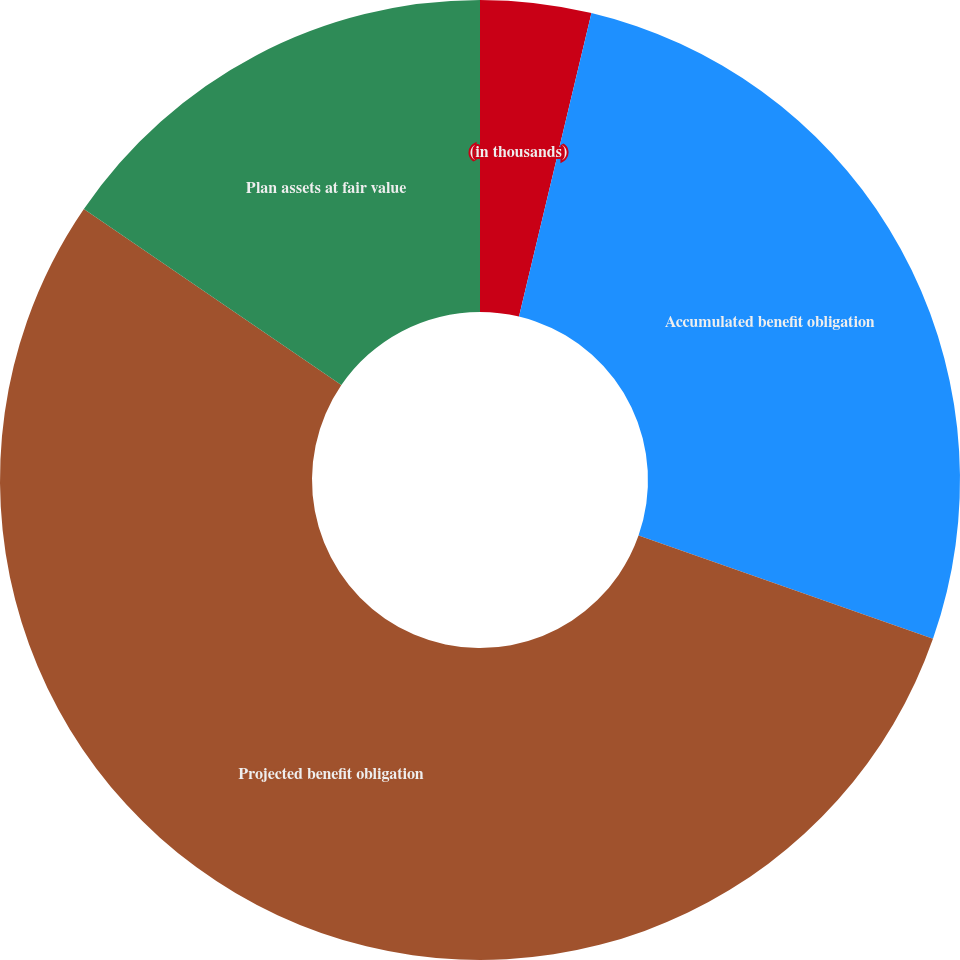Convert chart. <chart><loc_0><loc_0><loc_500><loc_500><pie_chart><fcel>(in thousands)<fcel>Accumulated benefit obligation<fcel>Projected benefit obligation<fcel>Plan assets at fair value<nl><fcel>3.73%<fcel>26.64%<fcel>54.19%<fcel>15.45%<nl></chart> 